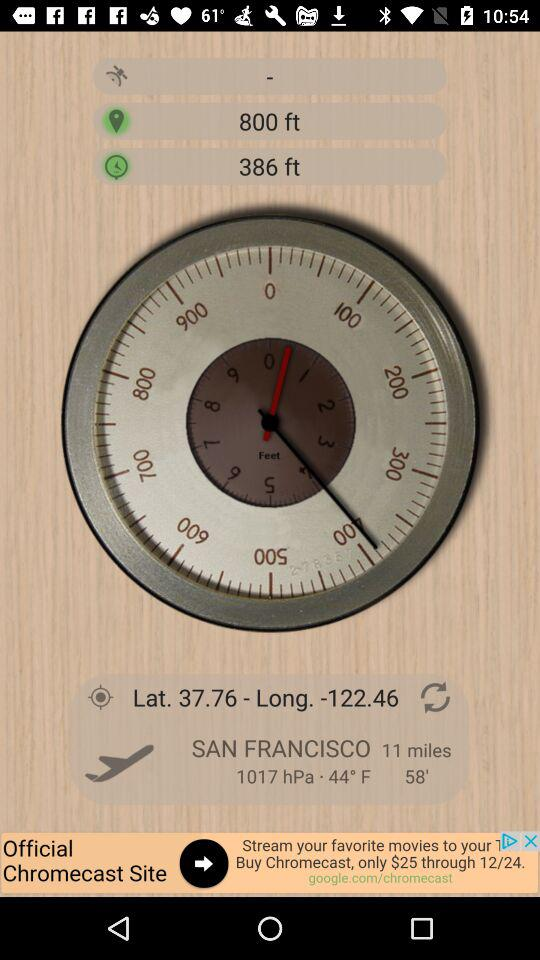What's the city name with latitude 37.76 and longitude 122.46? The city name is San Francisco. 